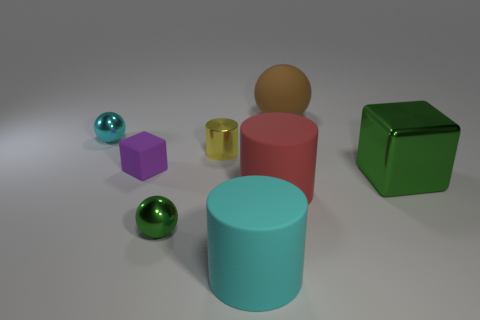Subtract all tiny shiny balls. How many balls are left? 1 Add 1 big cyan blocks. How many objects exist? 9 Subtract all balls. How many objects are left? 5 Add 1 small red blocks. How many small red blocks exist? 1 Subtract 0 blue cylinders. How many objects are left? 8 Subtract all green spheres. Subtract all small purple shiny cylinders. How many objects are left? 7 Add 4 metallic objects. How many metallic objects are left? 8 